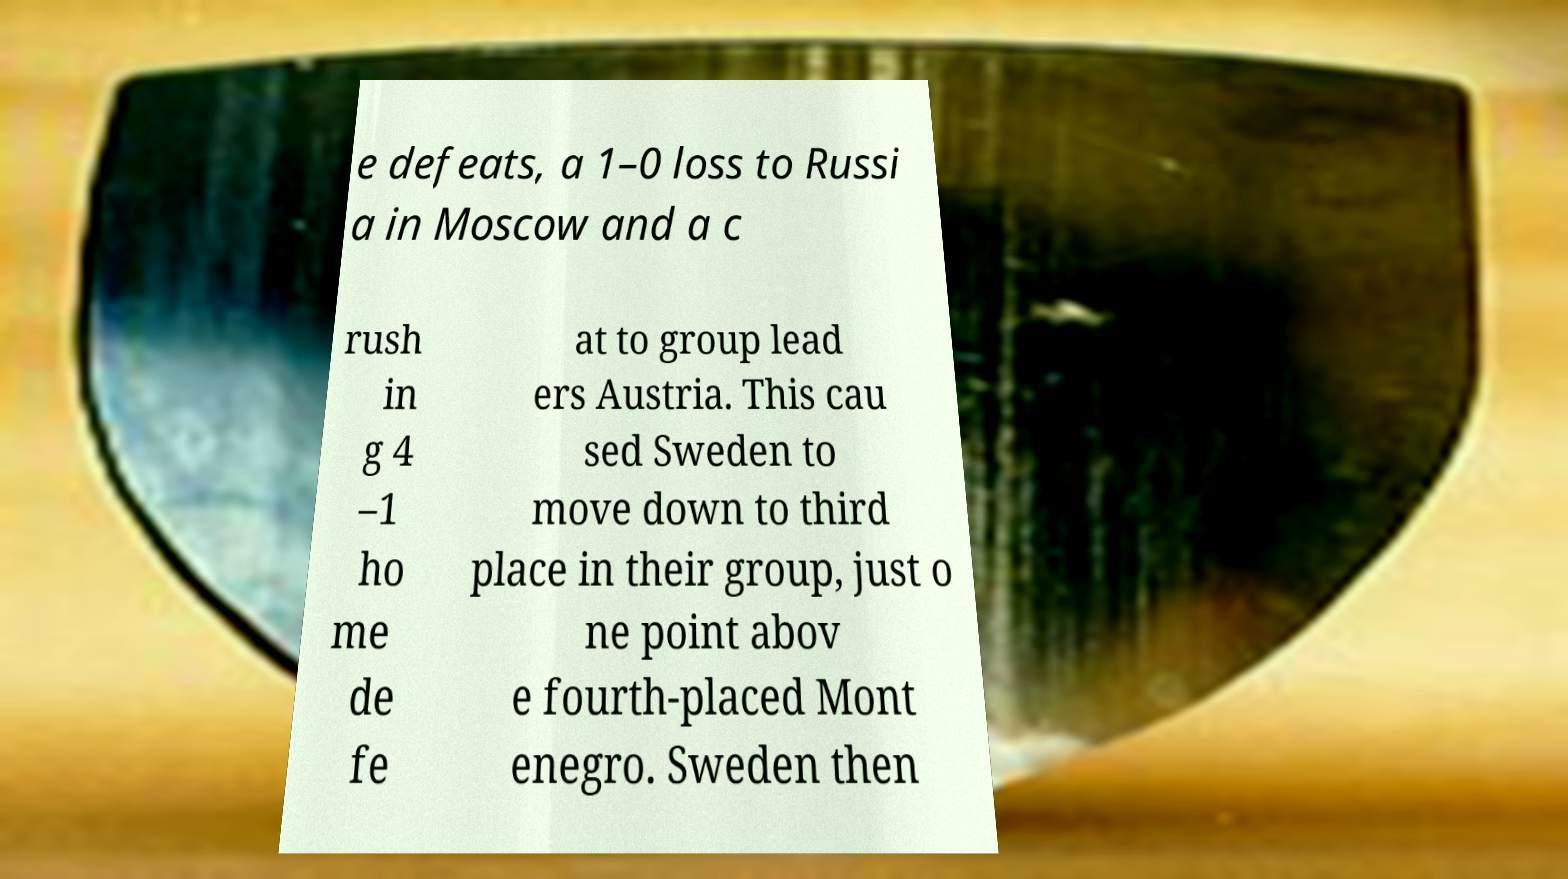Can you accurately transcribe the text from the provided image for me? e defeats, a 1–0 loss to Russi a in Moscow and a c rush in g 4 –1 ho me de fe at to group lead ers Austria. This cau sed Sweden to move down to third place in their group, just o ne point abov e fourth-placed Mont enegro. Sweden then 